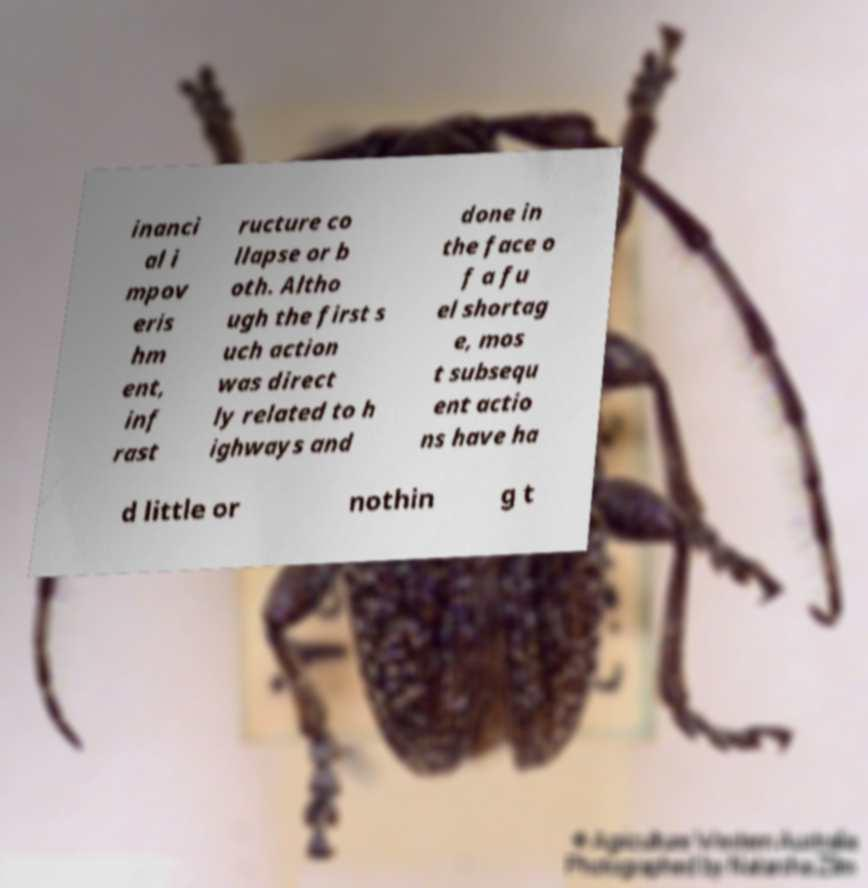I need the written content from this picture converted into text. Can you do that? inanci al i mpov eris hm ent, inf rast ructure co llapse or b oth. Altho ugh the first s uch action was direct ly related to h ighways and done in the face o f a fu el shortag e, mos t subsequ ent actio ns have ha d little or nothin g t 